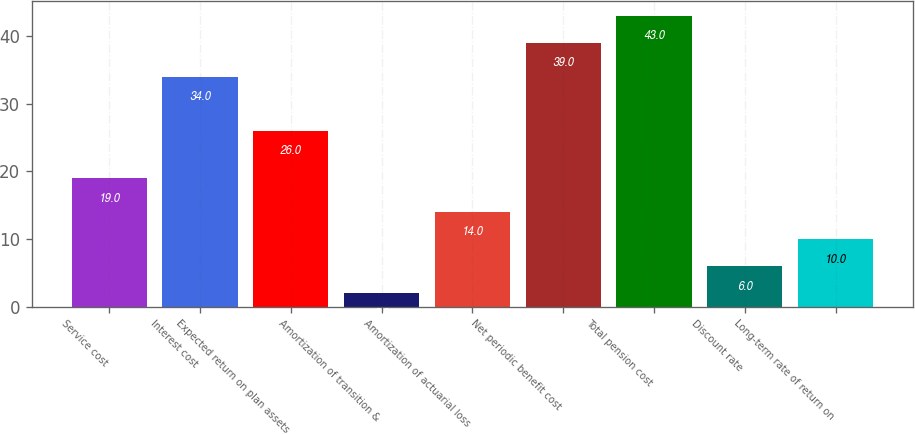Convert chart to OTSL. <chart><loc_0><loc_0><loc_500><loc_500><bar_chart><fcel>Service cost<fcel>Interest cost<fcel>Expected return on plan assets<fcel>Amortization of transition &<fcel>Amortization of actuarial loss<fcel>Net periodic benefit cost<fcel>Total pension cost<fcel>Discount rate<fcel>Long-term rate of return on<nl><fcel>19<fcel>34<fcel>26<fcel>2<fcel>14<fcel>39<fcel>43<fcel>6<fcel>10<nl></chart> 